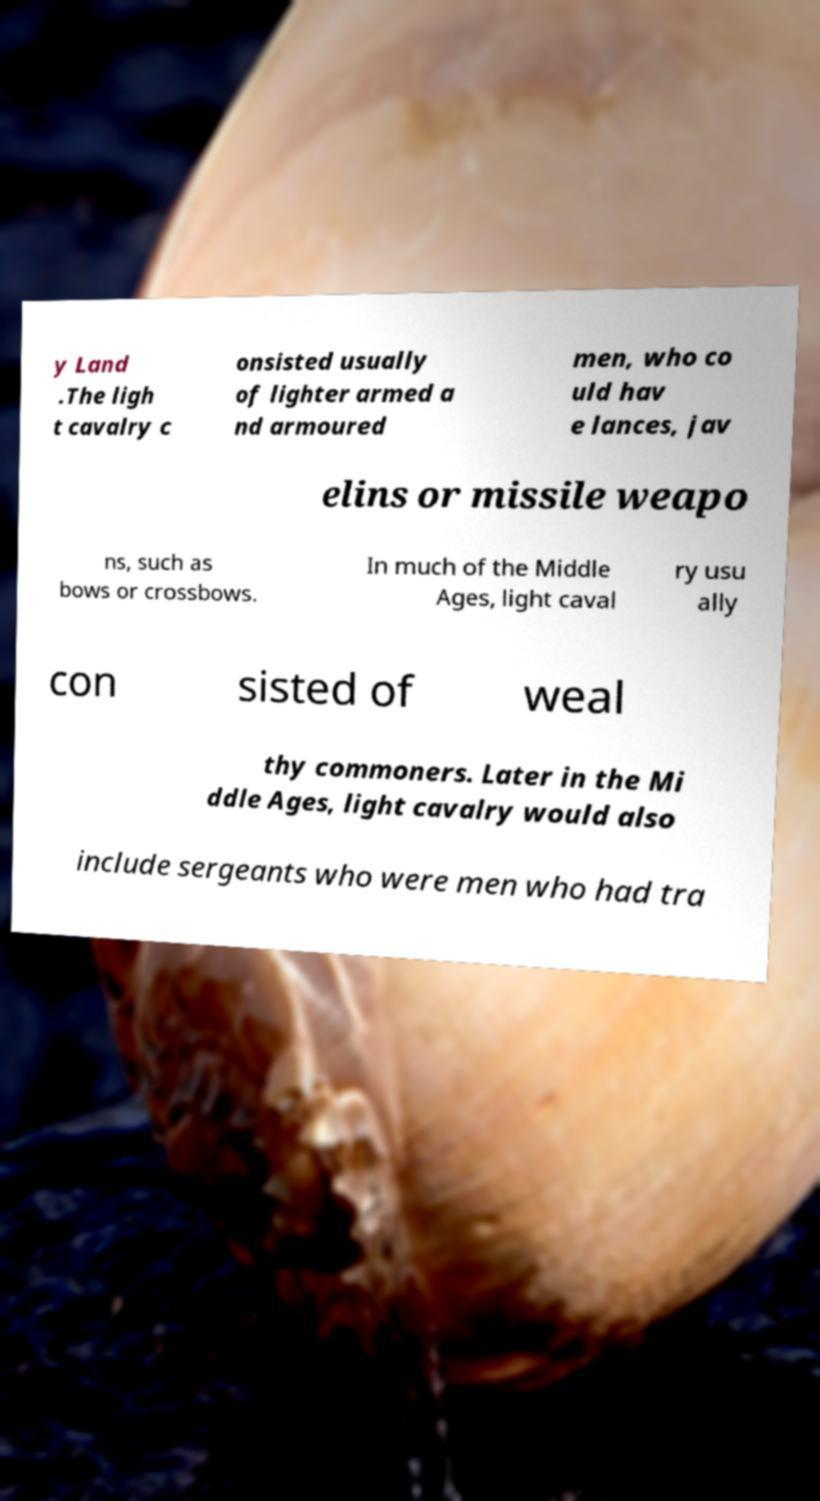I need the written content from this picture converted into text. Can you do that? y Land .The ligh t cavalry c onsisted usually of lighter armed a nd armoured men, who co uld hav e lances, jav elins or missile weapo ns, such as bows or crossbows. In much of the Middle Ages, light caval ry usu ally con sisted of weal thy commoners. Later in the Mi ddle Ages, light cavalry would also include sergeants who were men who had tra 